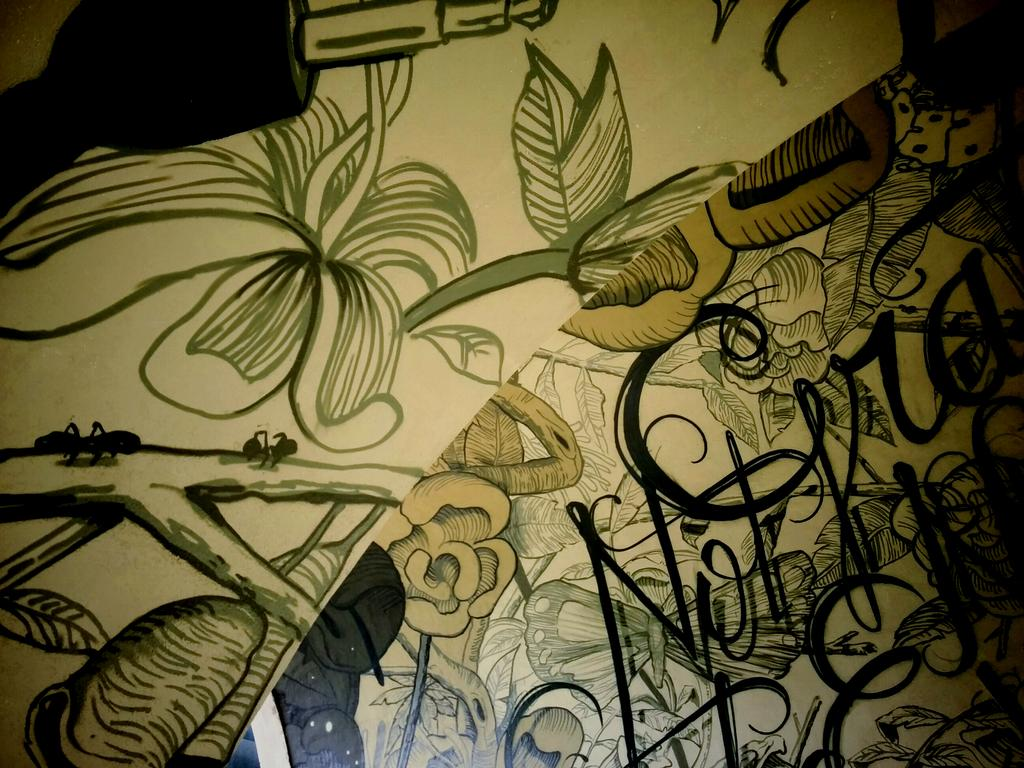What is the color of the paper in the image? The paper in the image is cream-colored. What can be seen on the surface of the paper? The paper has designs on it. Are there any words on the paper? Yes, there are words written on the paper. What type of giraffe can be seen in the image? There is no giraffe present in the image; it only features a cream-colored paper with designs and words. 